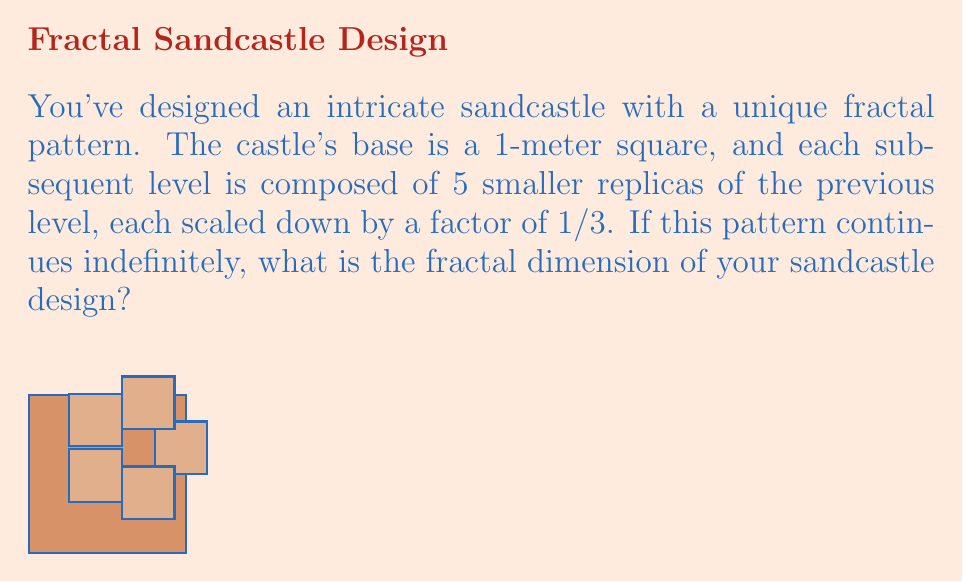Can you solve this math problem? To determine the fractal dimension of this sandcastle design, we'll use the box-counting method and the fractal dimension formula:

$$D = \frac{\log N}{\log (1/r)}$$

Where:
- $D$ is the fractal dimension
- $N$ is the number of self-similar pieces
- $r$ is the scale factor

For this sandcastle:
1. Number of self-similar pieces, $N = 5$
2. Scale factor, $r = 1/3$

Plugging these values into the formula:

$$D = \frac{\log 5}{\log (1/(1/3))} = \frac{\log 5}{\log 3}$$

Using a calculator or computer:

$$D \approx 1.4649$$

This fractal dimension lies between 1 and 2, which makes sense for a complex 2D pattern that partially fills the plane, but doesn't completely cover it like a 2D shape would.
Answer: $\frac{\log 5}{\log 3} \approx 1.4649$ 